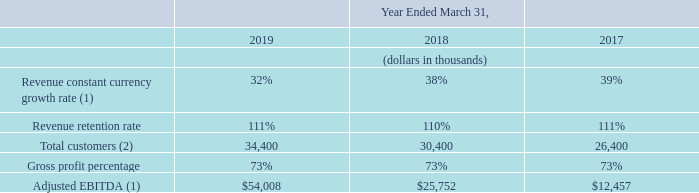Key Performance Indicators
In addition to traditional financial metrics, such as revenue and revenue growth trends, we monitor several other key performance indicators to help us evaluate growth trends, establish budgets, measure the effectiveness of our sales and marketing efforts and assess operational efficiencies. The key performance indicators that we monitor are as follows:
(1) Adjusted EBITDA and revenue constant currency growth rate are non-GAAP financial measures. For a reconciliation of Adjusted EBITDA and revenue constant currency growth rate to the nearest comparable GAAP measures, see Item 6. “Selected Financial Data.” (2) Reflects the customer count on the last day of the period rounded to the nearest hundred customers.
Revenue constant currency growth rate. We believe revenue constant currency growth rate is a key indicator of our operating results. We calculate revenue constant currency growth rate by translating revenue from entities reporting in foreign currencies into U.S. dollars using the comparable foreign currency exchange rates from the prior fiscal periods.
For further explanation of the uses and limitations of this non-GAAP measure and a reconciliation of our revenue constant currency growth rate to revenue, as reported, the most directly comparable U.S. GAAP measure, see Item 6. “Selected Financial Data.” As our total revenue grew over the past three years, our revenue constant currency growth rate has decreased over the same period, as the incremental growth from period to period represented a smaller percentage of total revenue as compared to the prior period.
As our total revenue grows, we expect our constant currency growth rate will decline as the incremental growth from period to period is expected to represent a smaller percentage of total revenue as compared to the prior period.
Revenue retention rate. We believe that our ability to retain customers is an indicator of the stability of our revenue base and the long-term value of our customer relationships. Our revenue retention rate is driven by our customer renewals and upsells. We calculate our revenue retention rate by annualizing constant currency revenue recorded on the last day of the measurement period for only those customers in place throughout the entire measurement period.
We include add-on, or upsell, revenue from additional employees and services purchased by existing customers. We divide the result by revenue on a constant currency basis on the first day of the measurement period for all customers in place at the beginning of the measurement period. The measurement period is the trailing twelve months.
The revenue on a constant currency basis is based on the average exchange rates in effect during the respective period. Our revenue retention rate in fiscal 2019 was relatively consistent with fiscal 2018. We expect our revenue retention rate to remain relatively consistent for fiscal 2020.
Total customers. We believe the total number of customers is a key indicator of our financial success and future revenue potential. We define a customer as an entity with an active subscription contract as of the measurement date. A customer is typically a parent company or, in a few cases, a significant subsidiary that works with us directly. We expect to continue to grow our customer base through the addition of new customers in each of our markets.
Gross profit percentage. Gross profit percentage is calculated as gross profit divided by revenue. Our gross profit percentage has been relatively consistent over the past three years; however, it has fluctuated and will continue to fluctuate on a quarterly basis due to timing of the addition of hardware and employees to serve our growing customer base. More recently, gross profit has also included amortization of intangible assets related to acquired businesses.
We provide our services in each of the regions in which we operate. Costs related to supporting and hosting our product offerings and delivering our services are incurred in the region in which the related revenue is recognized. As a result, our gross profit percentage in actual terms is consistent with gross profit on a constant currency basis.
Adjusted EBITDA. We believe that Adjusted EBITDA is a key indicator of our operating results. We define Adjusted EBITDA as net (loss) income, adjusted to exclude: depreciation, amortization, disposals and impairment of long-lived assets, acquisition-related gains and expenses, litigation-related expenses, share-based compensation expense, restructuring expense, interest income and interest expense, the provision for income taxes and foreign exchange income (expense).
Adjusted EBITDA also includes rent paid in the period related to locations that are accounted for as build-to-suit facilities. For further explanation of the uses and limitations of this non-GAAP measure and a reconciliation of our Adjusted EBITDA to the most directly comparable U.S. GAAP measure, net (loss) income, see Item 6. “Selected Financial Data.”
We expect that our Adjusted EBITDA will continue to increase; however, we expect that our operating expenses will also increase in absolute dollars as we focus on expanding our sales and marketing teams and growing our research and development capabilities.
How is Adjusted EBITDA defined? Net (loss) income, adjusted to exclude: depreciation, amortization, disposals and impairment of long-lived assets, acquisition-related gains and expenses, litigation-related expenses, share-based compensation expense, restructuring expense, interest income and interest expense, the provision for income taxes and foreign exchange income (expense). What was the Revenue constant currency growth rate in 2019, 2018 and 2017 respectively? 32%, 38%, 39%. What was the Revenue retention rate in 2019, 2018 and 2017 respectively? 111%, 110%, 111%. What is the change in the Revenue constant currency growth rate from 2018 to 2019?
Answer scale should be: percent. 32 - 38
Answer: -6. What is the average Total customers between 2017-2019? (34,400 + 30,400 + 26,400) / 3
Answer: 30400. In which year was Adjusted EBITDA less than 20,000 thousands? Locate and analyze adjusted ebitda in row 8
answer: 2017. 